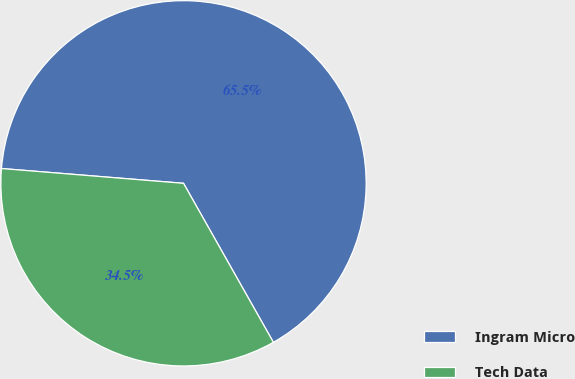<chart> <loc_0><loc_0><loc_500><loc_500><pie_chart><fcel>Ingram Micro<fcel>Tech Data<nl><fcel>65.52%<fcel>34.48%<nl></chart> 